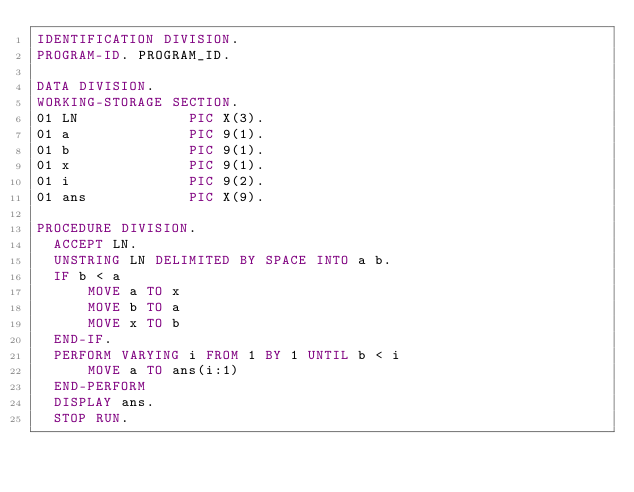<code> <loc_0><loc_0><loc_500><loc_500><_COBOL_>IDENTIFICATION DIVISION.
PROGRAM-ID. PROGRAM_ID.

DATA DIVISION.
WORKING-STORAGE SECTION.
01 LN             PIC X(3).
01 a              PIC 9(1).
01 b              PIC 9(1).
01 x              PIC 9(1).
01 i              PIC 9(2).
01 ans            PIC X(9).

PROCEDURE DIVISION.
  ACCEPT LN.
  UNSTRING LN DELIMITED BY SPACE INTO a b.
  IF b < a
      MOVE a TO x
      MOVE b TO a
      MOVE x TO b
  END-IF.
  PERFORM VARYING i FROM 1 BY 1 UNTIL b < i
      MOVE a TO ans(i:1)
  END-PERFORM
  DISPLAY ans.
  STOP RUN.
</code> 